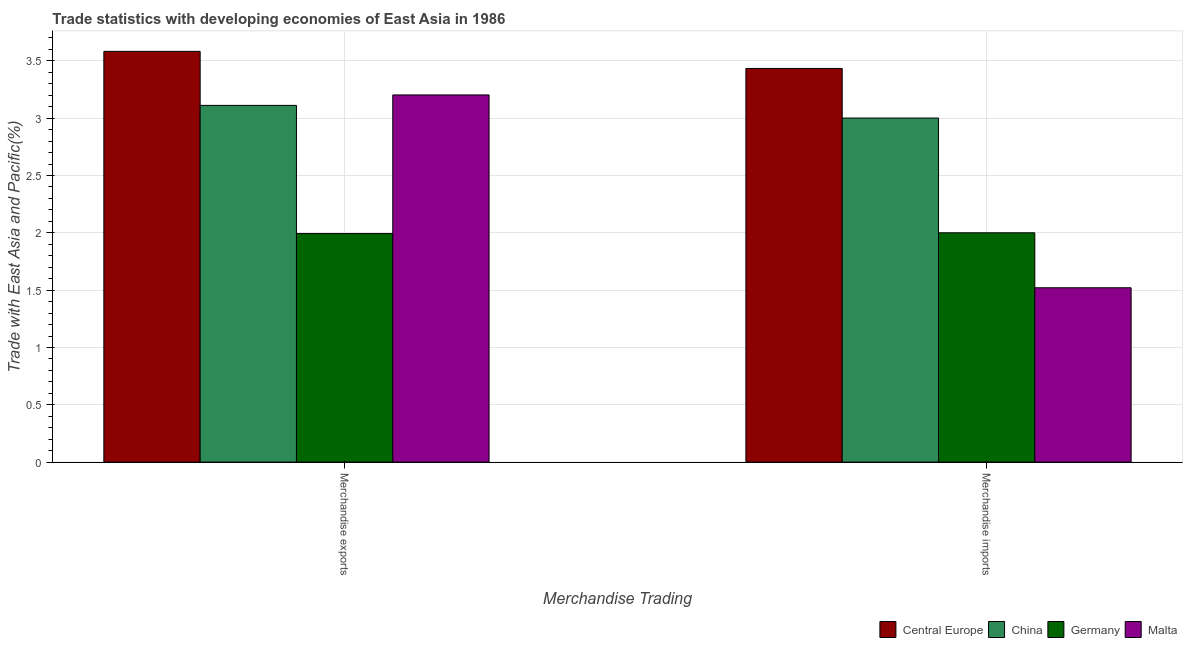How many different coloured bars are there?
Offer a very short reply. 4. How many groups of bars are there?
Provide a succinct answer. 2. Are the number of bars per tick equal to the number of legend labels?
Your answer should be compact. Yes. Are the number of bars on each tick of the X-axis equal?
Offer a terse response. Yes. How many bars are there on the 1st tick from the left?
Ensure brevity in your answer.  4. How many bars are there on the 1st tick from the right?
Offer a terse response. 4. What is the merchandise exports in Central Europe?
Make the answer very short. 3.58. Across all countries, what is the maximum merchandise exports?
Provide a succinct answer. 3.58. Across all countries, what is the minimum merchandise imports?
Your response must be concise. 1.52. In which country was the merchandise imports maximum?
Provide a short and direct response. Central Europe. In which country was the merchandise exports minimum?
Your response must be concise. Germany. What is the total merchandise exports in the graph?
Keep it short and to the point. 11.89. What is the difference between the merchandise imports in Malta and that in Germany?
Ensure brevity in your answer.  -0.48. What is the difference between the merchandise imports in Malta and the merchandise exports in China?
Keep it short and to the point. -1.59. What is the average merchandise imports per country?
Provide a succinct answer. 2.49. What is the difference between the merchandise imports and merchandise exports in Malta?
Ensure brevity in your answer.  -1.68. What is the ratio of the merchandise exports in Malta to that in China?
Provide a succinct answer. 1.03. Is the merchandise imports in Germany less than that in China?
Your answer should be compact. Yes. What does the 3rd bar from the left in Merchandise imports represents?
Keep it short and to the point. Germany. What does the 1st bar from the right in Merchandise imports represents?
Provide a succinct answer. Malta. How many bars are there?
Make the answer very short. 8. How many countries are there in the graph?
Provide a short and direct response. 4. Does the graph contain grids?
Your response must be concise. Yes. How many legend labels are there?
Your response must be concise. 4. How are the legend labels stacked?
Your answer should be very brief. Horizontal. What is the title of the graph?
Offer a terse response. Trade statistics with developing economies of East Asia in 1986. Does "Ghana" appear as one of the legend labels in the graph?
Your answer should be compact. No. What is the label or title of the X-axis?
Ensure brevity in your answer.  Merchandise Trading. What is the label or title of the Y-axis?
Your answer should be very brief. Trade with East Asia and Pacific(%). What is the Trade with East Asia and Pacific(%) in Central Europe in Merchandise exports?
Make the answer very short. 3.58. What is the Trade with East Asia and Pacific(%) in China in Merchandise exports?
Keep it short and to the point. 3.11. What is the Trade with East Asia and Pacific(%) in Germany in Merchandise exports?
Provide a succinct answer. 1.99. What is the Trade with East Asia and Pacific(%) of Malta in Merchandise exports?
Your answer should be very brief. 3.2. What is the Trade with East Asia and Pacific(%) in Central Europe in Merchandise imports?
Your response must be concise. 3.43. What is the Trade with East Asia and Pacific(%) of China in Merchandise imports?
Your response must be concise. 3. What is the Trade with East Asia and Pacific(%) of Germany in Merchandise imports?
Your answer should be compact. 2. What is the Trade with East Asia and Pacific(%) in Malta in Merchandise imports?
Your response must be concise. 1.52. Across all Merchandise Trading, what is the maximum Trade with East Asia and Pacific(%) of Central Europe?
Ensure brevity in your answer.  3.58. Across all Merchandise Trading, what is the maximum Trade with East Asia and Pacific(%) in China?
Ensure brevity in your answer.  3.11. Across all Merchandise Trading, what is the maximum Trade with East Asia and Pacific(%) in Germany?
Your answer should be compact. 2. Across all Merchandise Trading, what is the maximum Trade with East Asia and Pacific(%) in Malta?
Keep it short and to the point. 3.2. Across all Merchandise Trading, what is the minimum Trade with East Asia and Pacific(%) of Central Europe?
Give a very brief answer. 3.43. Across all Merchandise Trading, what is the minimum Trade with East Asia and Pacific(%) in China?
Your answer should be compact. 3. Across all Merchandise Trading, what is the minimum Trade with East Asia and Pacific(%) of Germany?
Offer a terse response. 1.99. Across all Merchandise Trading, what is the minimum Trade with East Asia and Pacific(%) of Malta?
Offer a terse response. 1.52. What is the total Trade with East Asia and Pacific(%) of Central Europe in the graph?
Provide a succinct answer. 7.02. What is the total Trade with East Asia and Pacific(%) in China in the graph?
Provide a short and direct response. 6.11. What is the total Trade with East Asia and Pacific(%) of Germany in the graph?
Offer a terse response. 3.99. What is the total Trade with East Asia and Pacific(%) of Malta in the graph?
Ensure brevity in your answer.  4.72. What is the difference between the Trade with East Asia and Pacific(%) of Central Europe in Merchandise exports and that in Merchandise imports?
Keep it short and to the point. 0.15. What is the difference between the Trade with East Asia and Pacific(%) in China in Merchandise exports and that in Merchandise imports?
Offer a very short reply. 0.11. What is the difference between the Trade with East Asia and Pacific(%) in Germany in Merchandise exports and that in Merchandise imports?
Offer a terse response. -0.01. What is the difference between the Trade with East Asia and Pacific(%) of Malta in Merchandise exports and that in Merchandise imports?
Your response must be concise. 1.68. What is the difference between the Trade with East Asia and Pacific(%) of Central Europe in Merchandise exports and the Trade with East Asia and Pacific(%) of China in Merchandise imports?
Provide a succinct answer. 0.58. What is the difference between the Trade with East Asia and Pacific(%) of Central Europe in Merchandise exports and the Trade with East Asia and Pacific(%) of Germany in Merchandise imports?
Make the answer very short. 1.58. What is the difference between the Trade with East Asia and Pacific(%) in Central Europe in Merchandise exports and the Trade with East Asia and Pacific(%) in Malta in Merchandise imports?
Ensure brevity in your answer.  2.06. What is the difference between the Trade with East Asia and Pacific(%) in China in Merchandise exports and the Trade with East Asia and Pacific(%) in Germany in Merchandise imports?
Ensure brevity in your answer.  1.11. What is the difference between the Trade with East Asia and Pacific(%) of China in Merchandise exports and the Trade with East Asia and Pacific(%) of Malta in Merchandise imports?
Your answer should be very brief. 1.59. What is the difference between the Trade with East Asia and Pacific(%) in Germany in Merchandise exports and the Trade with East Asia and Pacific(%) in Malta in Merchandise imports?
Give a very brief answer. 0.47. What is the average Trade with East Asia and Pacific(%) of Central Europe per Merchandise Trading?
Your answer should be very brief. 3.51. What is the average Trade with East Asia and Pacific(%) in China per Merchandise Trading?
Ensure brevity in your answer.  3.06. What is the average Trade with East Asia and Pacific(%) of Germany per Merchandise Trading?
Give a very brief answer. 2. What is the average Trade with East Asia and Pacific(%) of Malta per Merchandise Trading?
Provide a short and direct response. 2.36. What is the difference between the Trade with East Asia and Pacific(%) in Central Europe and Trade with East Asia and Pacific(%) in China in Merchandise exports?
Your response must be concise. 0.47. What is the difference between the Trade with East Asia and Pacific(%) of Central Europe and Trade with East Asia and Pacific(%) of Germany in Merchandise exports?
Your answer should be compact. 1.59. What is the difference between the Trade with East Asia and Pacific(%) of Central Europe and Trade with East Asia and Pacific(%) of Malta in Merchandise exports?
Your answer should be compact. 0.38. What is the difference between the Trade with East Asia and Pacific(%) of China and Trade with East Asia and Pacific(%) of Germany in Merchandise exports?
Provide a succinct answer. 1.12. What is the difference between the Trade with East Asia and Pacific(%) of China and Trade with East Asia and Pacific(%) of Malta in Merchandise exports?
Keep it short and to the point. -0.09. What is the difference between the Trade with East Asia and Pacific(%) of Germany and Trade with East Asia and Pacific(%) of Malta in Merchandise exports?
Keep it short and to the point. -1.21. What is the difference between the Trade with East Asia and Pacific(%) in Central Europe and Trade with East Asia and Pacific(%) in China in Merchandise imports?
Your answer should be very brief. 0.43. What is the difference between the Trade with East Asia and Pacific(%) of Central Europe and Trade with East Asia and Pacific(%) of Germany in Merchandise imports?
Your answer should be very brief. 1.43. What is the difference between the Trade with East Asia and Pacific(%) in Central Europe and Trade with East Asia and Pacific(%) in Malta in Merchandise imports?
Your answer should be very brief. 1.91. What is the difference between the Trade with East Asia and Pacific(%) in China and Trade with East Asia and Pacific(%) in Malta in Merchandise imports?
Give a very brief answer. 1.48. What is the difference between the Trade with East Asia and Pacific(%) of Germany and Trade with East Asia and Pacific(%) of Malta in Merchandise imports?
Keep it short and to the point. 0.48. What is the ratio of the Trade with East Asia and Pacific(%) in Central Europe in Merchandise exports to that in Merchandise imports?
Your response must be concise. 1.04. What is the ratio of the Trade with East Asia and Pacific(%) in China in Merchandise exports to that in Merchandise imports?
Offer a very short reply. 1.04. What is the ratio of the Trade with East Asia and Pacific(%) in Malta in Merchandise exports to that in Merchandise imports?
Offer a very short reply. 2.11. What is the difference between the highest and the second highest Trade with East Asia and Pacific(%) of Central Europe?
Your response must be concise. 0.15. What is the difference between the highest and the second highest Trade with East Asia and Pacific(%) of China?
Your answer should be very brief. 0.11. What is the difference between the highest and the second highest Trade with East Asia and Pacific(%) of Germany?
Provide a succinct answer. 0.01. What is the difference between the highest and the second highest Trade with East Asia and Pacific(%) of Malta?
Ensure brevity in your answer.  1.68. What is the difference between the highest and the lowest Trade with East Asia and Pacific(%) of Central Europe?
Ensure brevity in your answer.  0.15. What is the difference between the highest and the lowest Trade with East Asia and Pacific(%) of China?
Make the answer very short. 0.11. What is the difference between the highest and the lowest Trade with East Asia and Pacific(%) of Germany?
Provide a succinct answer. 0.01. What is the difference between the highest and the lowest Trade with East Asia and Pacific(%) of Malta?
Your answer should be very brief. 1.68. 